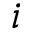<formula> <loc_0><loc_0><loc_500><loc_500>i</formula> 